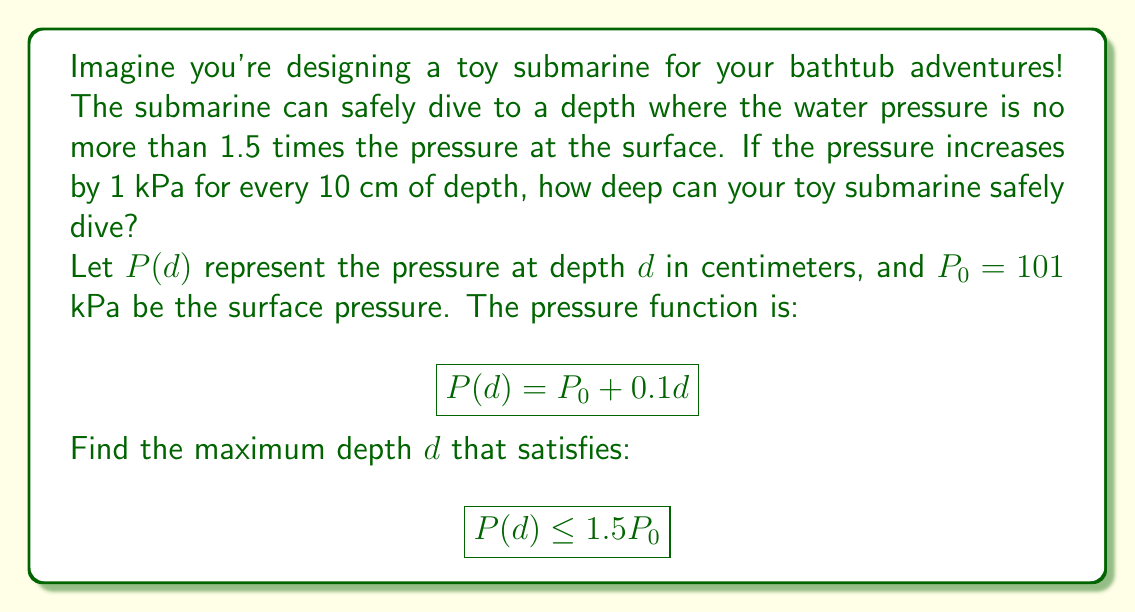Provide a solution to this math problem. Let's solve this step-by-step:

1) We know that the pressure at depth $d$ is given by:
   $$P(d) = P_0 + 0.1d$$

2) We want to find the maximum depth where:
   $$P(d) \leq 1.5P_0$$

3) Substituting the pressure function:
   $$P_0 + 0.1d \leq 1.5P_0$$

4) Simplify by subtracting $P_0$ from both sides:
   $$0.1d \leq 0.5P_0$$

5) Divide both sides by 0.1:
   $$d \leq 5P_0$$

6) Now, substitute the value of $P_0 = 101$ kPa:
   $$d \leq 5 \times 101 = 505$$

Therefore, the maximum safe depth is 505 cm.

7) To convert to meters, divide by 100:
   $$505 \text{ cm} = 5.05 \text{ m}$$

So, your toy submarine can safely dive to a depth of 5.05 meters.
Answer: 5.05 m 